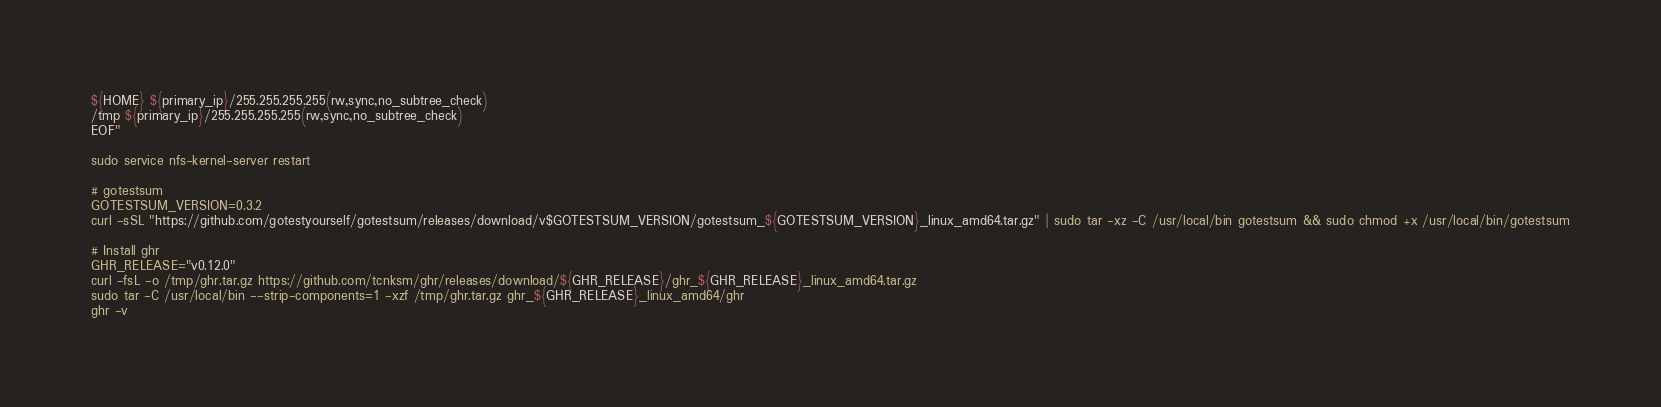<code> <loc_0><loc_0><loc_500><loc_500><_Bash_>${HOME} ${primary_ip}/255.255.255.255(rw,sync,no_subtree_check)
/tmp ${primary_ip}/255.255.255.255(rw,sync,no_subtree_check)
EOF"

sudo service nfs-kernel-server restart

# gotestsum
GOTESTSUM_VERSION=0.3.2
curl -sSL "https://github.com/gotestyourself/gotestsum/releases/download/v$GOTESTSUM_VERSION/gotestsum_${GOTESTSUM_VERSION}_linux_amd64.tar.gz" | sudo tar -xz -C /usr/local/bin gotestsum && sudo chmod +x /usr/local/bin/gotestsum

# Install ghr
GHR_RELEASE="v0.12.0"
curl -fsL -o /tmp/ghr.tar.gz https://github.com/tcnksm/ghr/releases/download/${GHR_RELEASE}/ghr_${GHR_RELEASE}_linux_amd64.tar.gz
sudo tar -C /usr/local/bin --strip-components=1 -xzf /tmp/ghr.tar.gz ghr_${GHR_RELEASE}_linux_amd64/ghr
ghr -v
</code> 